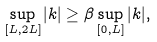Convert formula to latex. <formula><loc_0><loc_0><loc_500><loc_500>\sup _ { [ L , 2 L ] } | k | \geq \beta \sup _ { [ 0 , L ] } | k | ,</formula> 